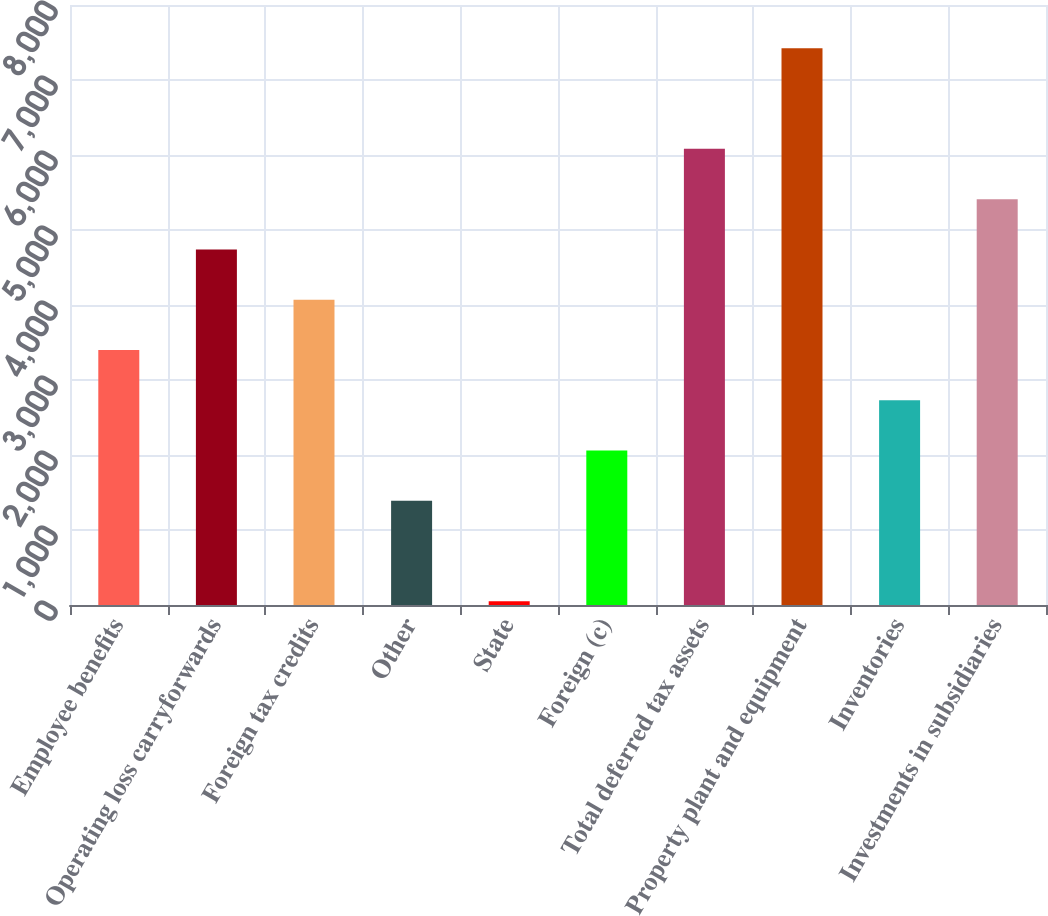Convert chart. <chart><loc_0><loc_0><loc_500><loc_500><bar_chart><fcel>Employee benefits<fcel>Operating loss carryforwards<fcel>Foreign tax credits<fcel>Other<fcel>State<fcel>Foreign (c)<fcel>Total deferred tax assets<fcel>Property plant and equipment<fcel>Inventories<fcel>Investments in subsidiaries<nl><fcel>3401<fcel>4741.4<fcel>4071.2<fcel>1390.4<fcel>50<fcel>2060.6<fcel>6081.8<fcel>7422.2<fcel>2730.8<fcel>5411.6<nl></chart> 